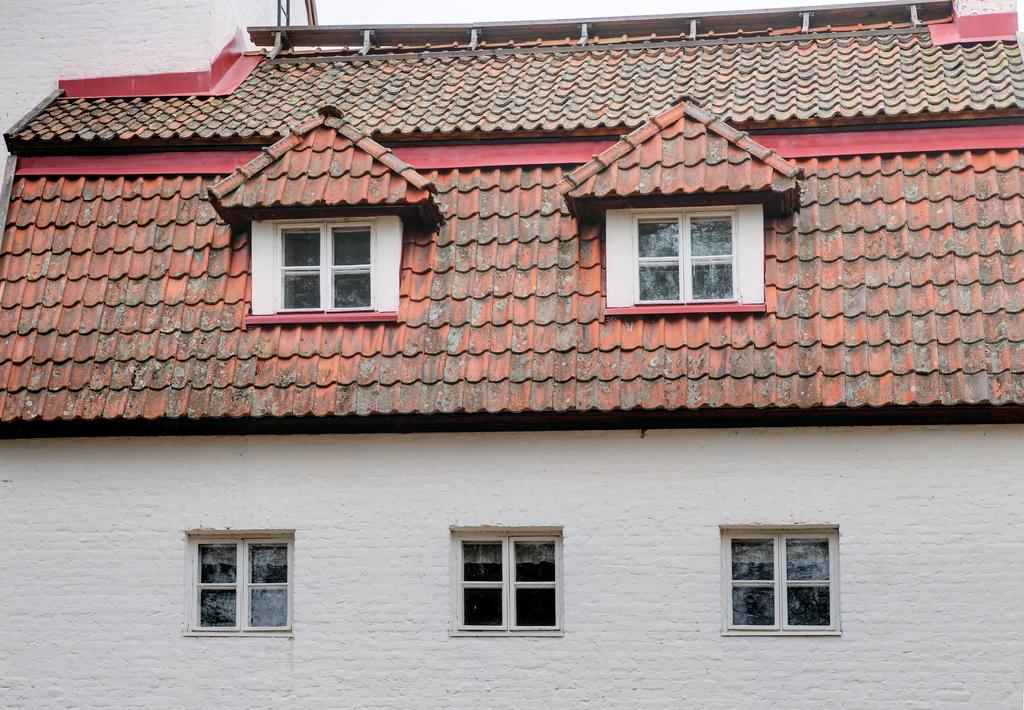What type of structure is visible in the image? There is a roof top and a wall visible in the image. What can be seen on the roof top? The provided facts do not mention any specific details about the roof top. Are there any openings in the wall? Yes, there are windows visible in the image. What type of shop can be seen on the roof top in the image? There is no shop visible on the roof top in the image. How many carriages are parked near the wall in the image? There are no carriages present in the image. 